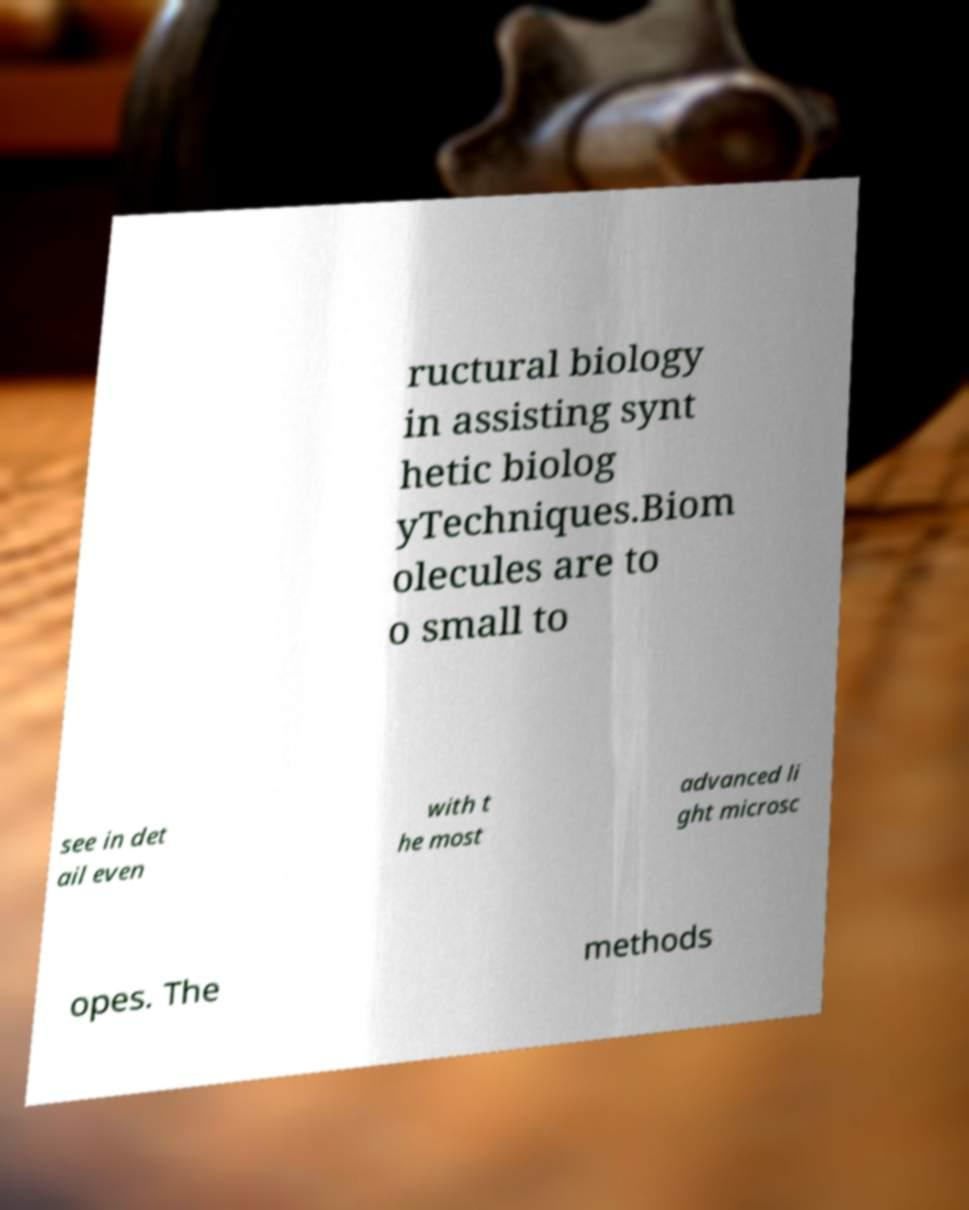For documentation purposes, I need the text within this image transcribed. Could you provide that? ructural biology in assisting synt hetic biolog yTechniques.Biom olecules are to o small to see in det ail even with t he most advanced li ght microsc opes. The methods 